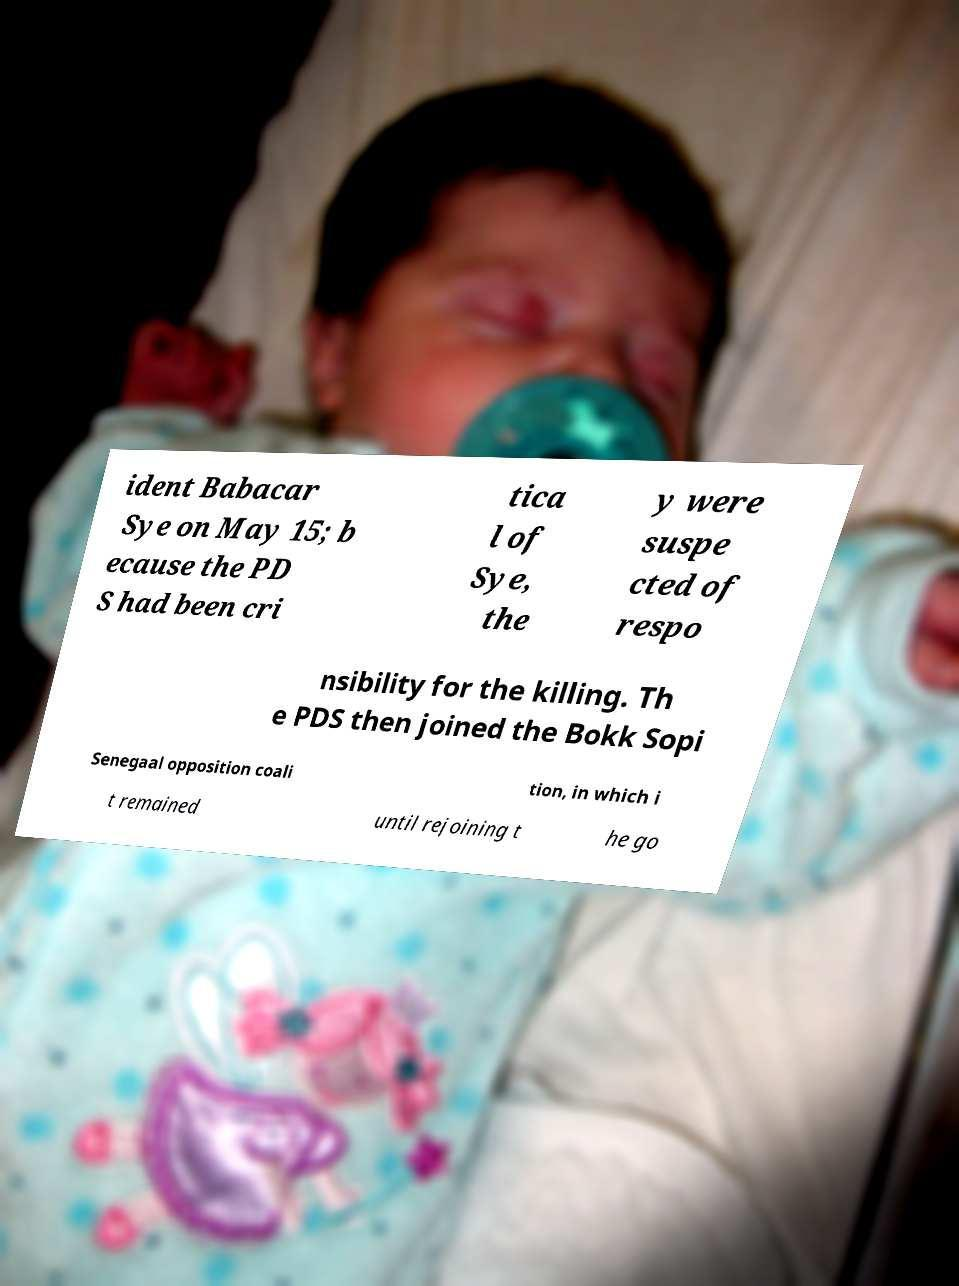Could you assist in decoding the text presented in this image and type it out clearly? ident Babacar Sye on May 15; b ecause the PD S had been cri tica l of Sye, the y were suspe cted of respo nsibility for the killing. Th e PDS then joined the Bokk Sopi Senegaal opposition coali tion, in which i t remained until rejoining t he go 